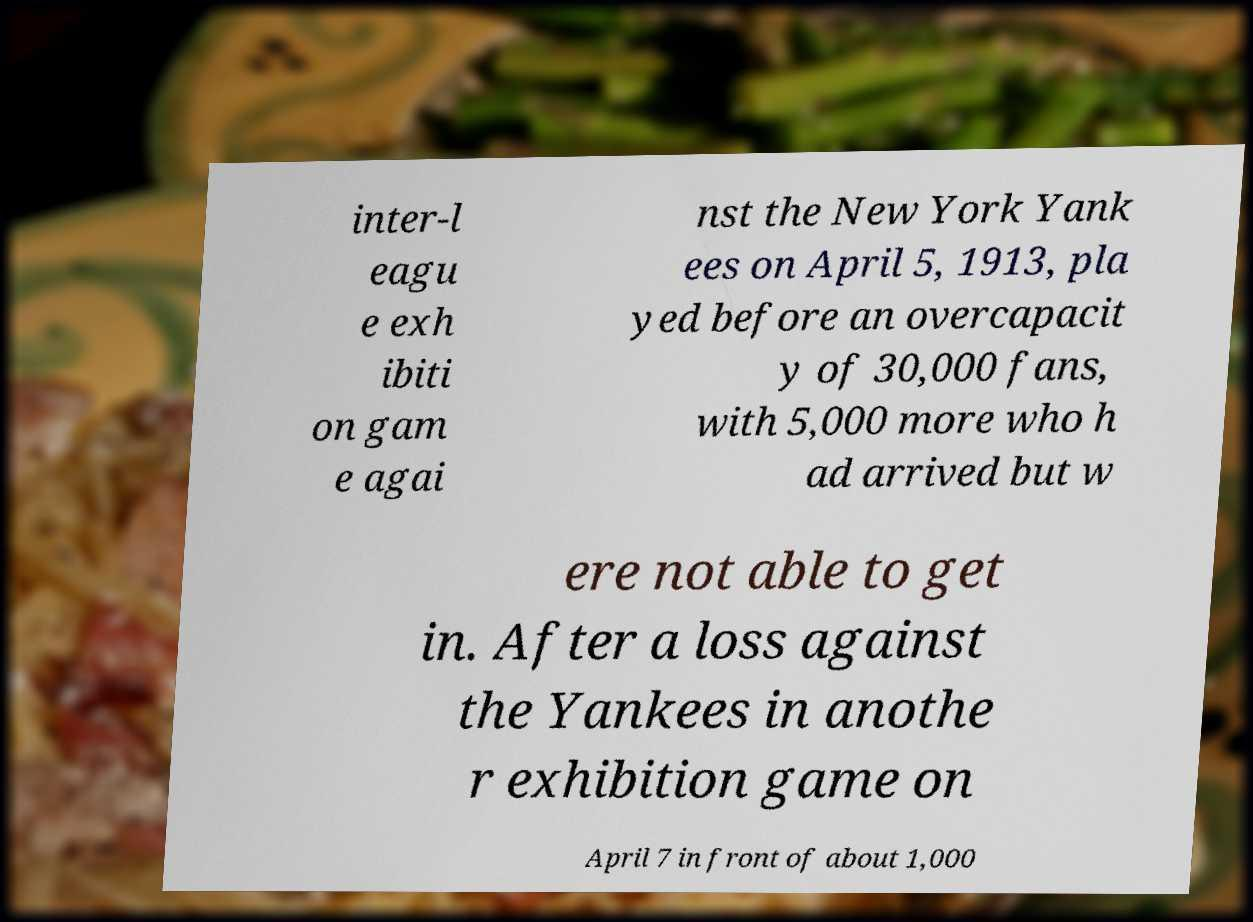Could you assist in decoding the text presented in this image and type it out clearly? inter-l eagu e exh ibiti on gam e agai nst the New York Yank ees on April 5, 1913, pla yed before an overcapacit y of 30,000 fans, with 5,000 more who h ad arrived but w ere not able to get in. After a loss against the Yankees in anothe r exhibition game on April 7 in front of about 1,000 